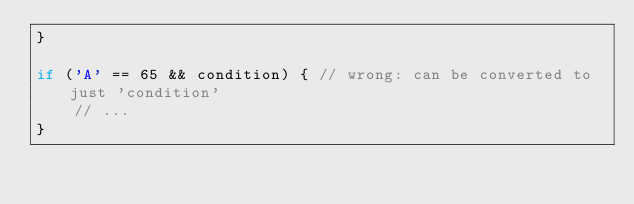<code> <loc_0><loc_0><loc_500><loc_500><_C++_>}

if ('A' == 65 && condition) { // wrong: can be converted to just 'condition'
	// ...
}
</code> 